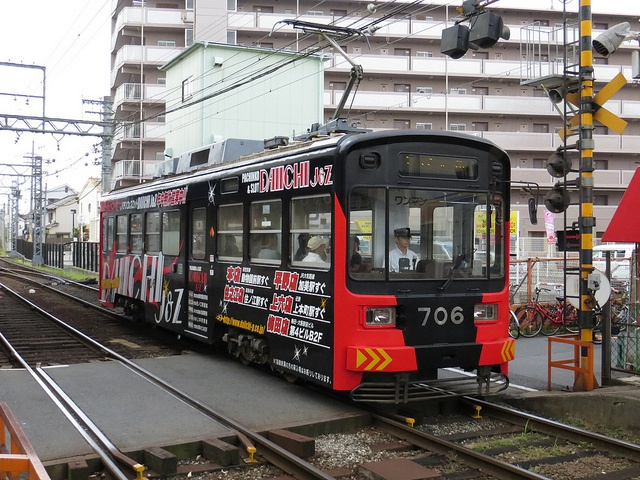Describe the objects in this image and their specific colors. I can see train in white, black, gray, darkgray, and brown tones, bicycle in white, black, maroon, and gray tones, traffic light in white, gray, and black tones, people in white, darkgray, gray, and black tones, and people in white, darkgray, gray, and lightgray tones in this image. 